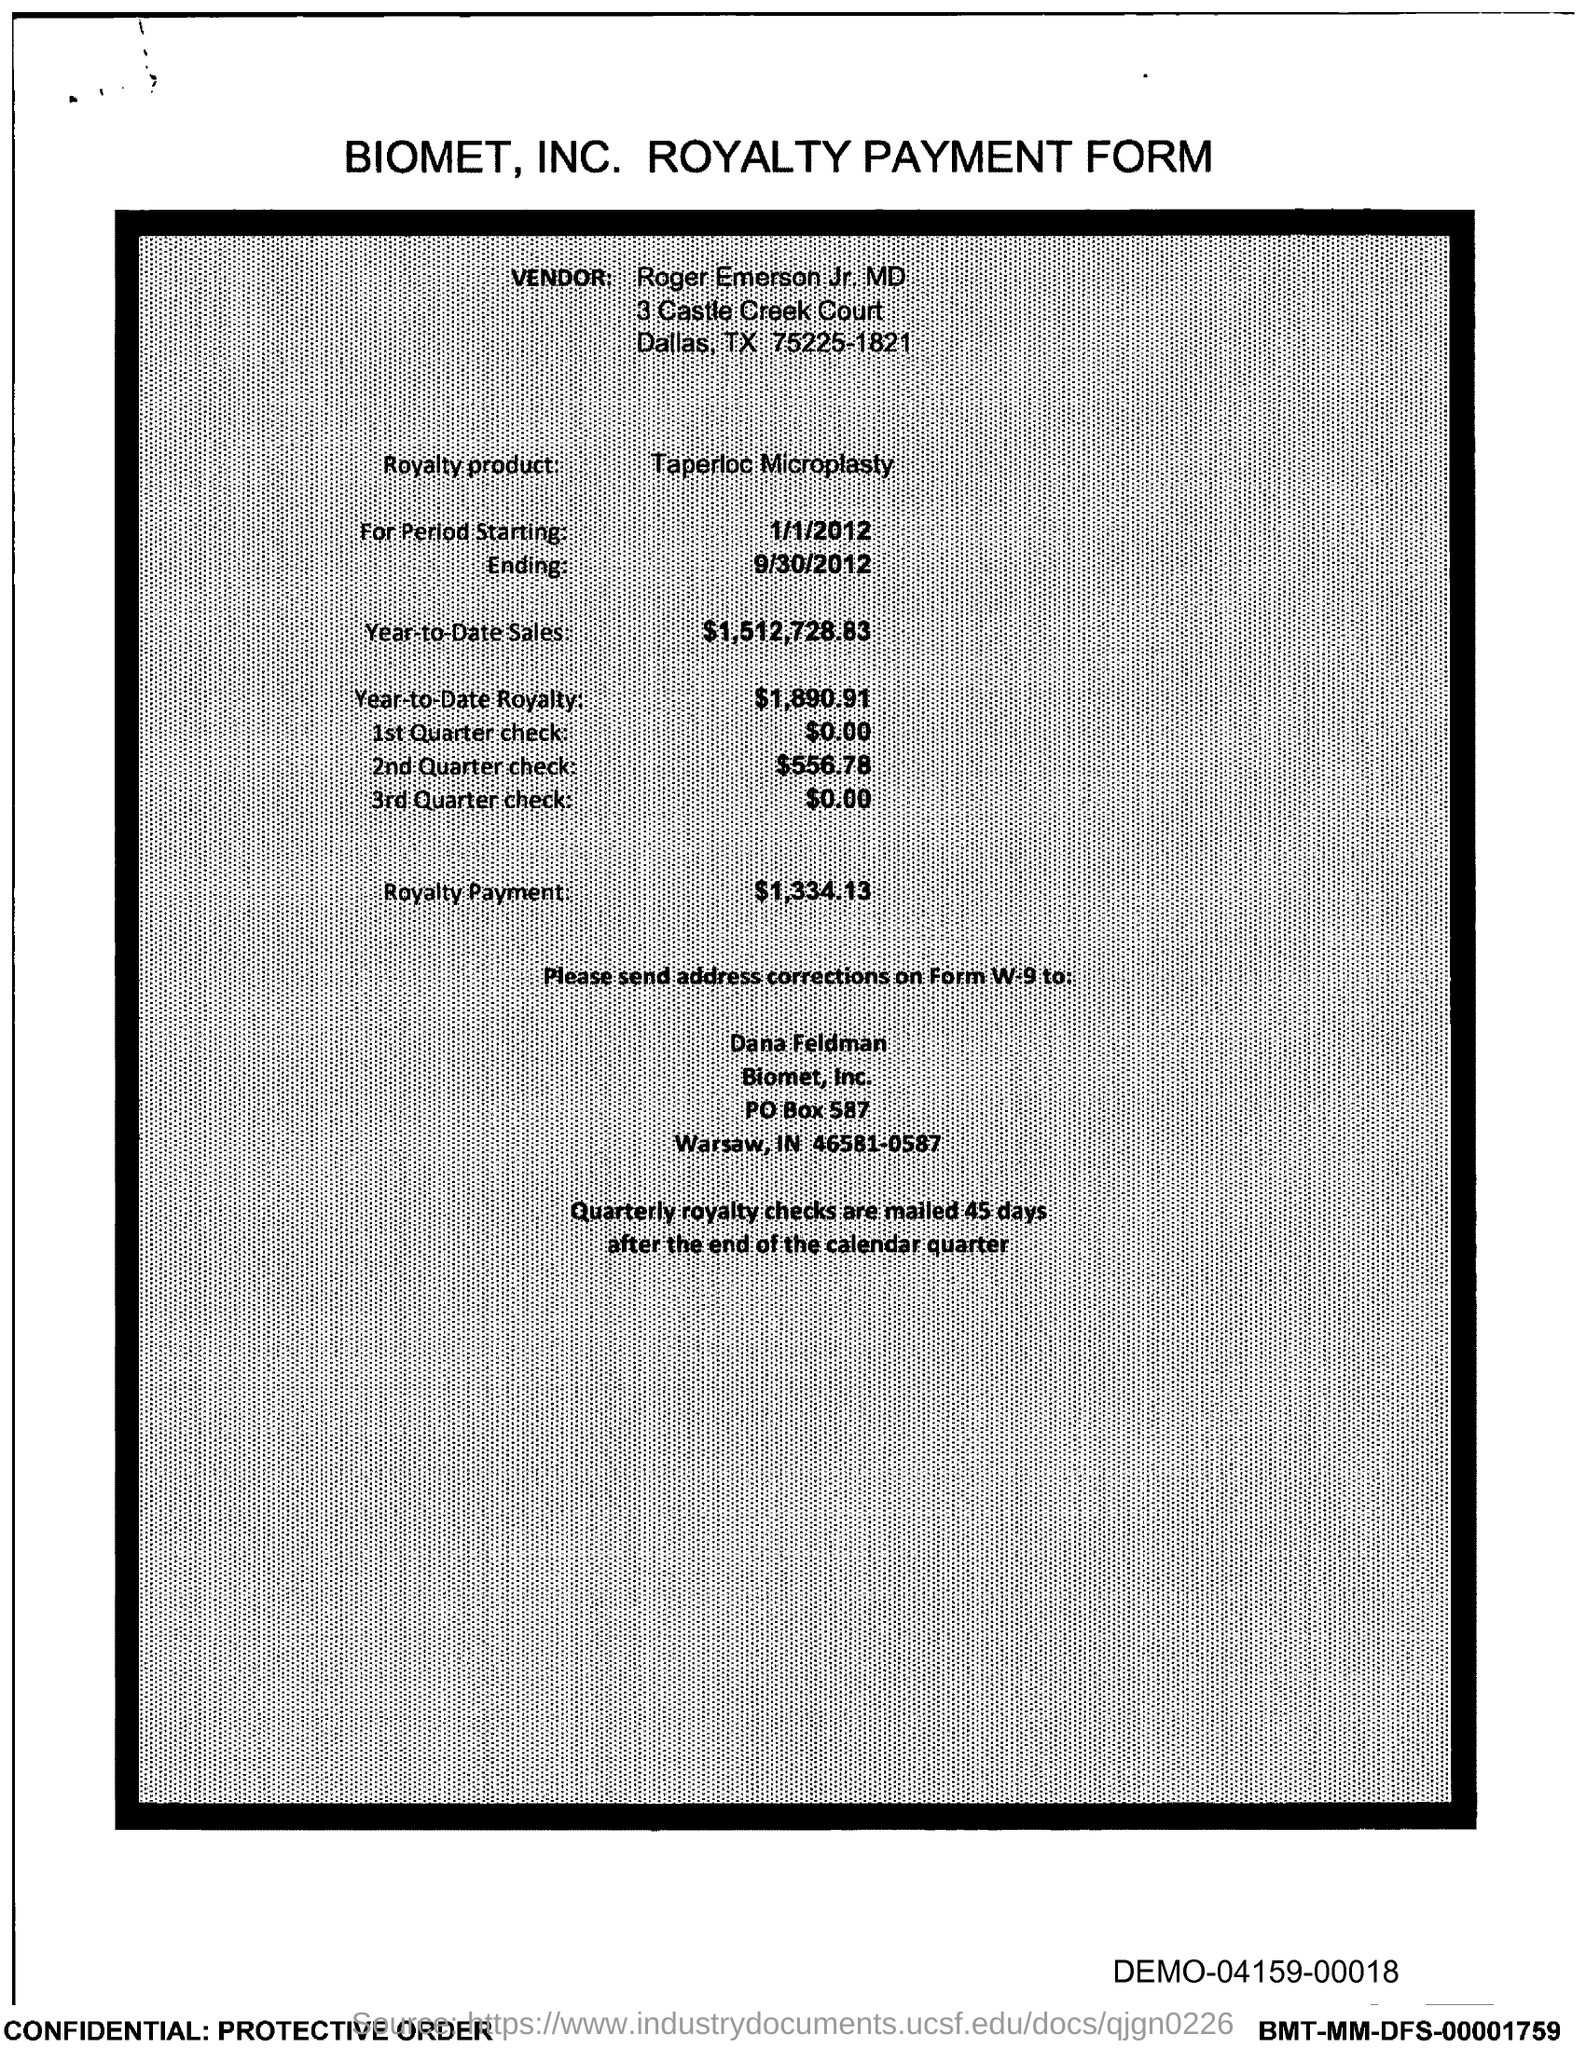Give some essential details in this illustration. The royalty payment for the product mentioned in the form is $1,334.13. The vendor name provided in the form is Roger Emerson Jr. MD. The amount of the 2nd quarter check mentioned in the form is $556.78. Taperloc Microplasty is the royalty product mentioned in the form. The amount of the 1st quarter check mentioned in the form is $0.00. 